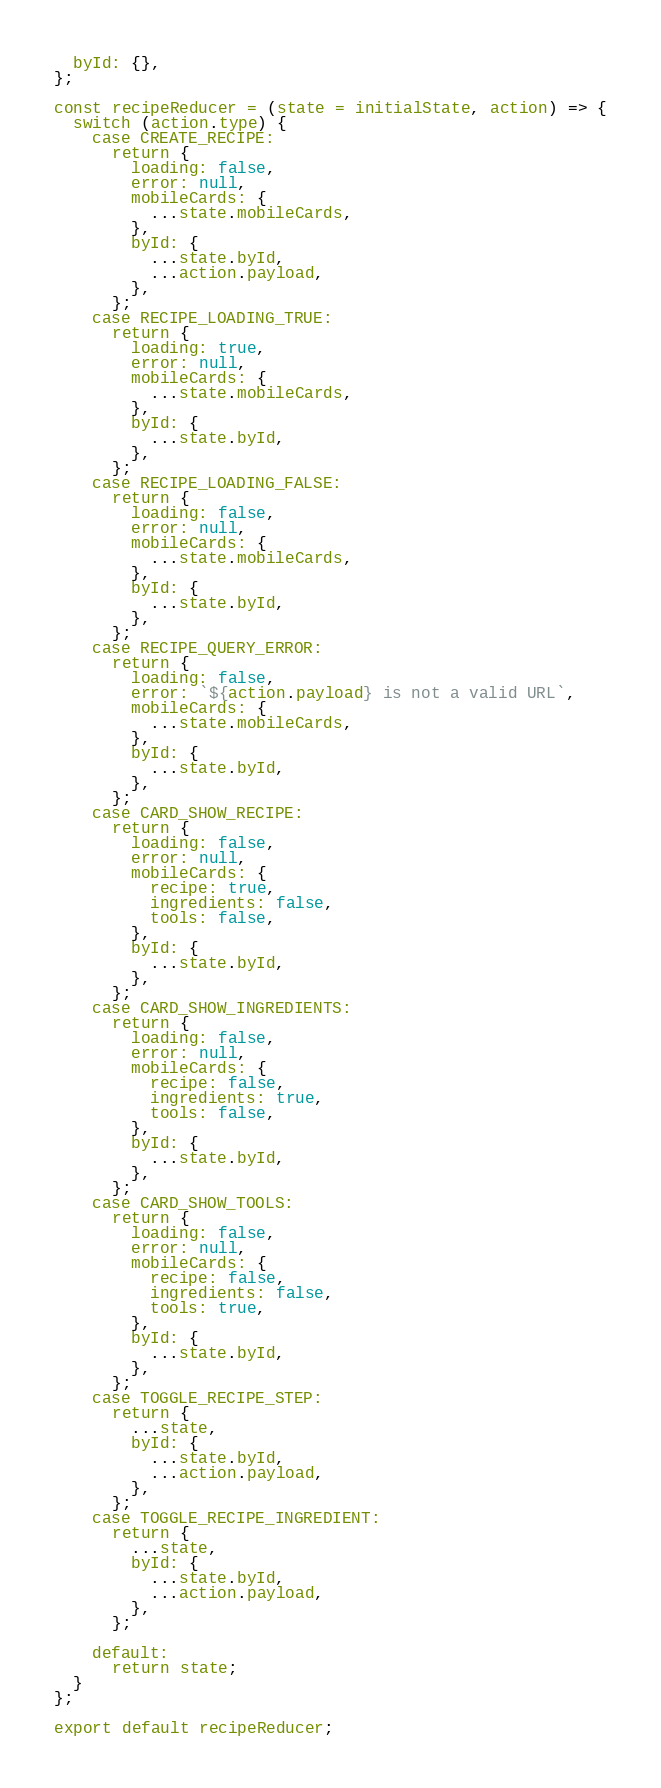<code> <loc_0><loc_0><loc_500><loc_500><_JavaScript_>  byId: {},
};

const recipeReducer = (state = initialState, action) => {
  switch (action.type) {
    case CREATE_RECIPE:
      return {
        loading: false,
        error: null,
        mobileCards: {
          ...state.mobileCards,
        },
        byId: {
          ...state.byId,
          ...action.payload,
        },
      };
    case RECIPE_LOADING_TRUE:
      return {
        loading: true,
        error: null,
        mobileCards: {
          ...state.mobileCards,
        },
        byId: {
          ...state.byId,
        },
      };
    case RECIPE_LOADING_FALSE:
      return {
        loading: false,
        error: null,
        mobileCards: {
          ...state.mobileCards,
        },
        byId: {
          ...state.byId,
        },
      };
    case RECIPE_QUERY_ERROR:
      return {
        loading: false,
        error: `${action.payload} is not a valid URL`,
        mobileCards: {
          ...state.mobileCards,
        },
        byId: {
          ...state.byId,
        },
      };
    case CARD_SHOW_RECIPE:
      return {
        loading: false,
        error: null,
        mobileCards: {
          recipe: true,
          ingredients: false,
          tools: false,
        },
        byId: {
          ...state.byId,
        },
      };
    case CARD_SHOW_INGREDIENTS:
      return {
        loading: false,
        error: null,
        mobileCards: {
          recipe: false,
          ingredients: true,
          tools: false,
        },
        byId: {
          ...state.byId,
        },
      };
    case CARD_SHOW_TOOLS:
      return {
        loading: false,
        error: null,
        mobileCards: {
          recipe: false,
          ingredients: false,
          tools: true,
        },
        byId: {
          ...state.byId,
        },
      };
    case TOGGLE_RECIPE_STEP:
      return {
        ...state,
        byId: {
          ...state.byId,
          ...action.payload,
        },
      };
    case TOGGLE_RECIPE_INGREDIENT:
      return {
        ...state,
        byId: {
          ...state.byId,
          ...action.payload,
        },
      };

    default:
      return state;
  }
};

export default recipeReducer;
</code> 